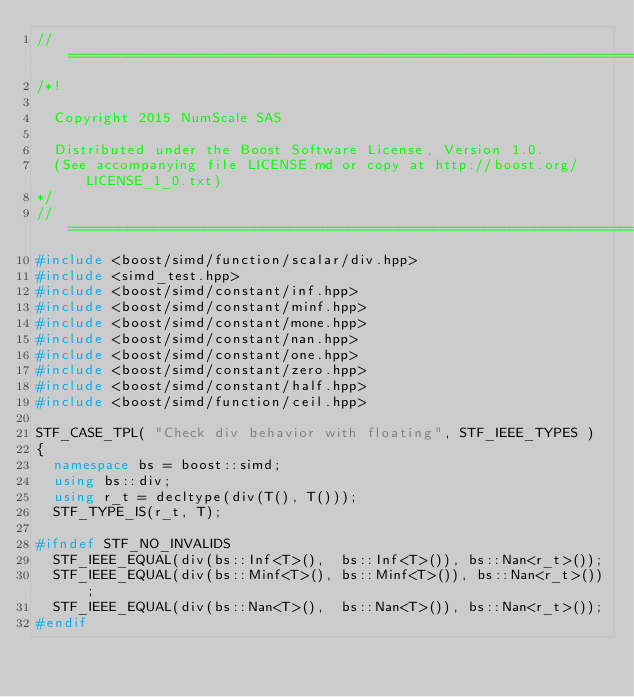<code> <loc_0><loc_0><loc_500><loc_500><_C++_>//==================================================================================================
/*!

  Copyright 2015 NumScale SAS

  Distributed under the Boost Software License, Version 1.0.
  (See accompanying file LICENSE.md or copy at http://boost.org/LICENSE_1_0.txt)
*/
//==================================================================================================
#include <boost/simd/function/scalar/div.hpp>
#include <simd_test.hpp>
#include <boost/simd/constant/inf.hpp>
#include <boost/simd/constant/minf.hpp>
#include <boost/simd/constant/mone.hpp>
#include <boost/simd/constant/nan.hpp>
#include <boost/simd/constant/one.hpp>
#include <boost/simd/constant/zero.hpp>
#include <boost/simd/constant/half.hpp>
#include <boost/simd/function/ceil.hpp>

STF_CASE_TPL( "Check div behavior with floating", STF_IEEE_TYPES )
{
  namespace bs = boost::simd;
  using bs::div;
  using r_t = decltype(div(T(), T()));
  STF_TYPE_IS(r_t, T);

#ifndef STF_NO_INVALIDS
  STF_IEEE_EQUAL(div(bs::Inf<T>(),  bs::Inf<T>()), bs::Nan<r_t>());
  STF_IEEE_EQUAL(div(bs::Minf<T>(), bs::Minf<T>()), bs::Nan<r_t>());
  STF_IEEE_EQUAL(div(bs::Nan<T>(),  bs::Nan<T>()), bs::Nan<r_t>());
#endif</code> 